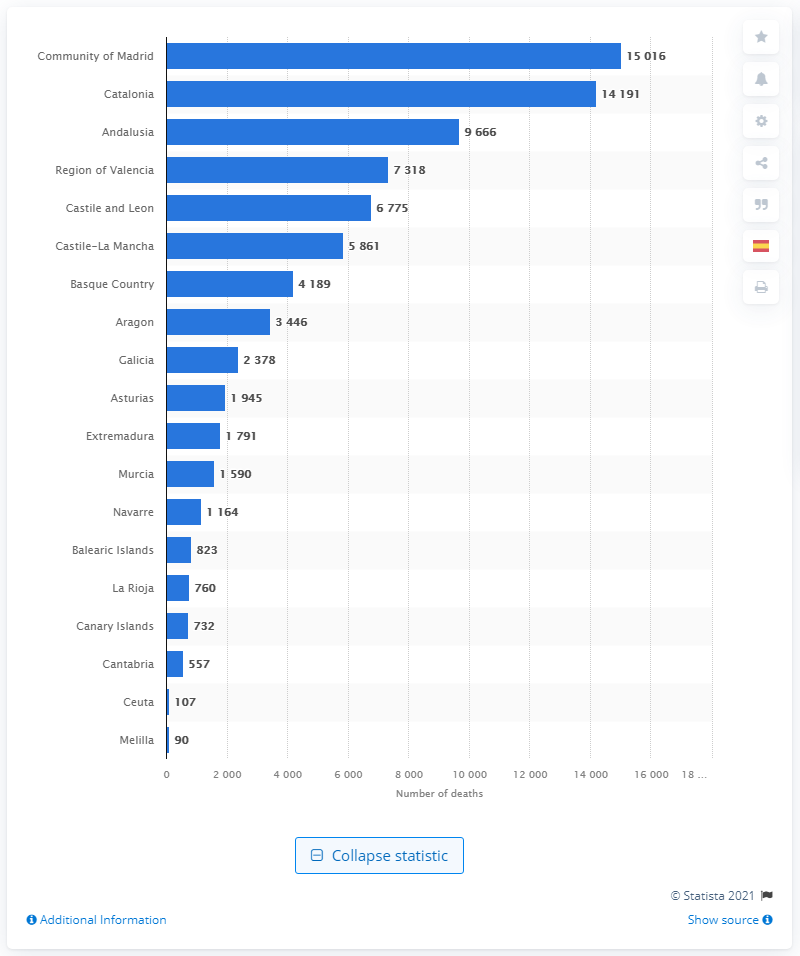Can you tell me which region has the second-highest number of deaths due to coronavirus as per the chart? The region with the second-highest number of deaths due to coronavirus according to the chart is Catalonia, with 14,191 deaths. 